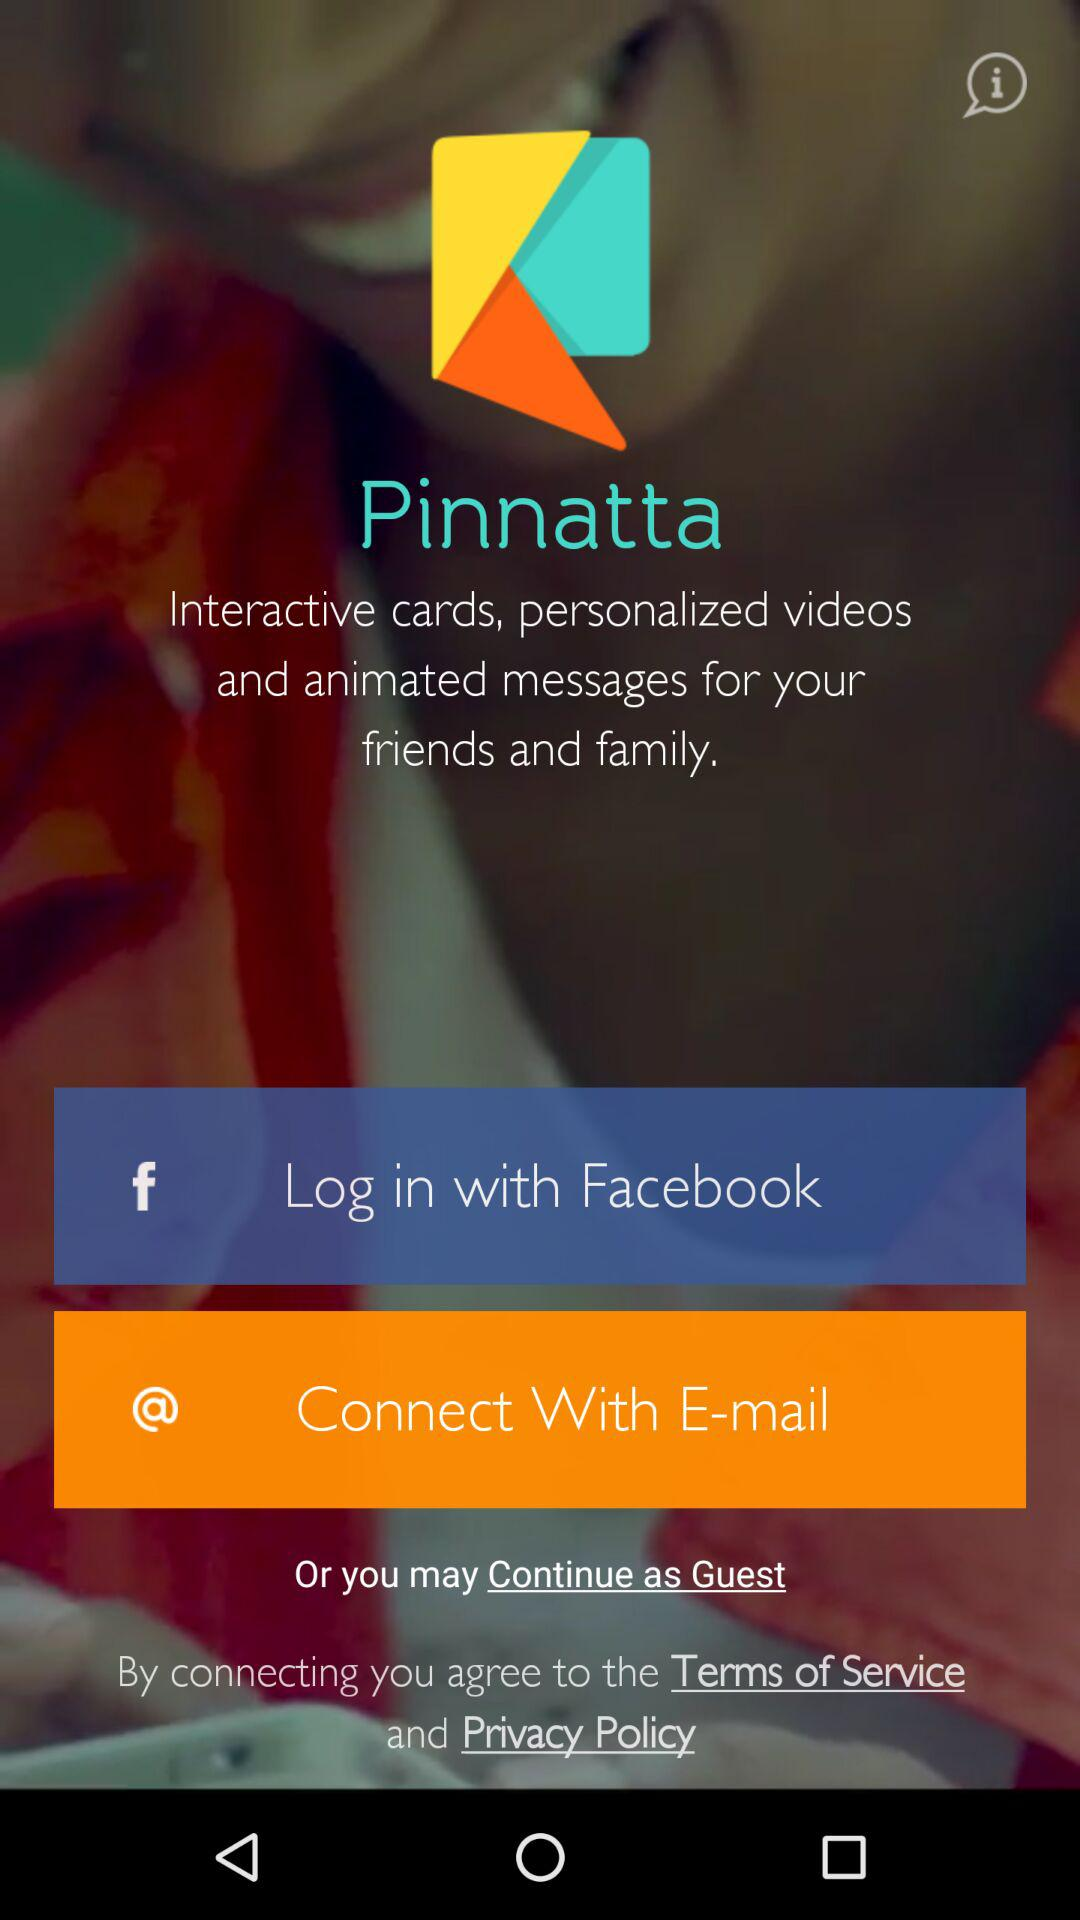What are the options to login? The options are "Facebook" and "E-mail". 